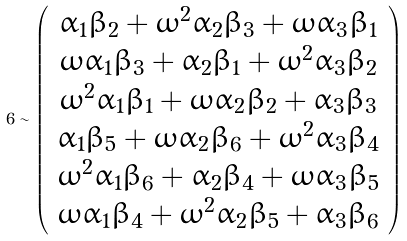Convert formula to latex. <formula><loc_0><loc_0><loc_500><loc_500>6 \sim \left ( \begin{array} { c } \alpha _ { 1 } \beta _ { 2 } + \omega ^ { 2 } \alpha _ { 2 } \beta _ { 3 } + \omega \alpha _ { 3 } \beta _ { 1 } \\ \omega \alpha _ { 1 } \beta _ { 3 } + \alpha _ { 2 } \beta _ { 1 } + \omega ^ { 2 } \alpha _ { 3 } \beta _ { 2 } \\ \omega ^ { 2 } \alpha _ { 1 } \beta _ { 1 } + \omega \alpha _ { 2 } \beta _ { 2 } + \alpha _ { 3 } \beta _ { 3 } \\ \alpha _ { 1 } \beta _ { 5 } + \omega \alpha _ { 2 } \beta _ { 6 } + \omega ^ { 2 } \alpha _ { 3 } \beta _ { 4 } \\ \omega ^ { 2 } \alpha _ { 1 } \beta _ { 6 } + \alpha _ { 2 } \beta _ { 4 } + \omega \alpha _ { 3 } \beta _ { 5 } \\ \omega \alpha _ { 1 } \beta _ { 4 } + \omega ^ { 2 } \alpha _ { 2 } \beta _ { 5 } + \alpha _ { 3 } \beta _ { 6 } \end{array} \right )</formula> 